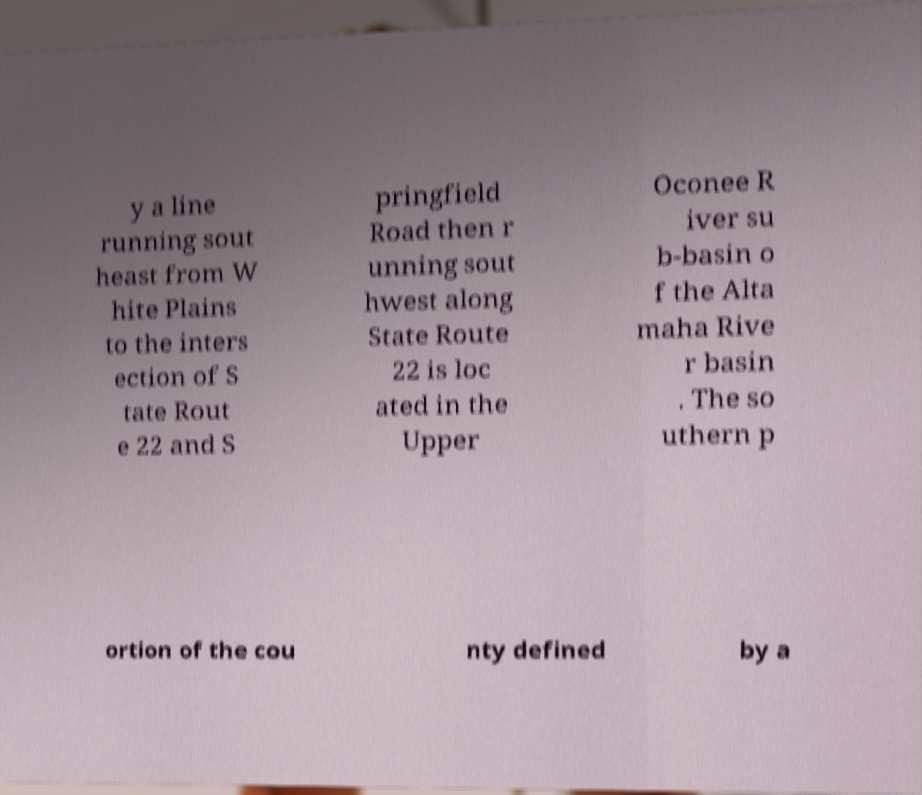Please identify and transcribe the text found in this image. y a line running sout heast from W hite Plains to the inters ection of S tate Rout e 22 and S pringfield Road then r unning sout hwest along State Route 22 is loc ated in the Upper Oconee R iver su b-basin o f the Alta maha Rive r basin . The so uthern p ortion of the cou nty defined by a 